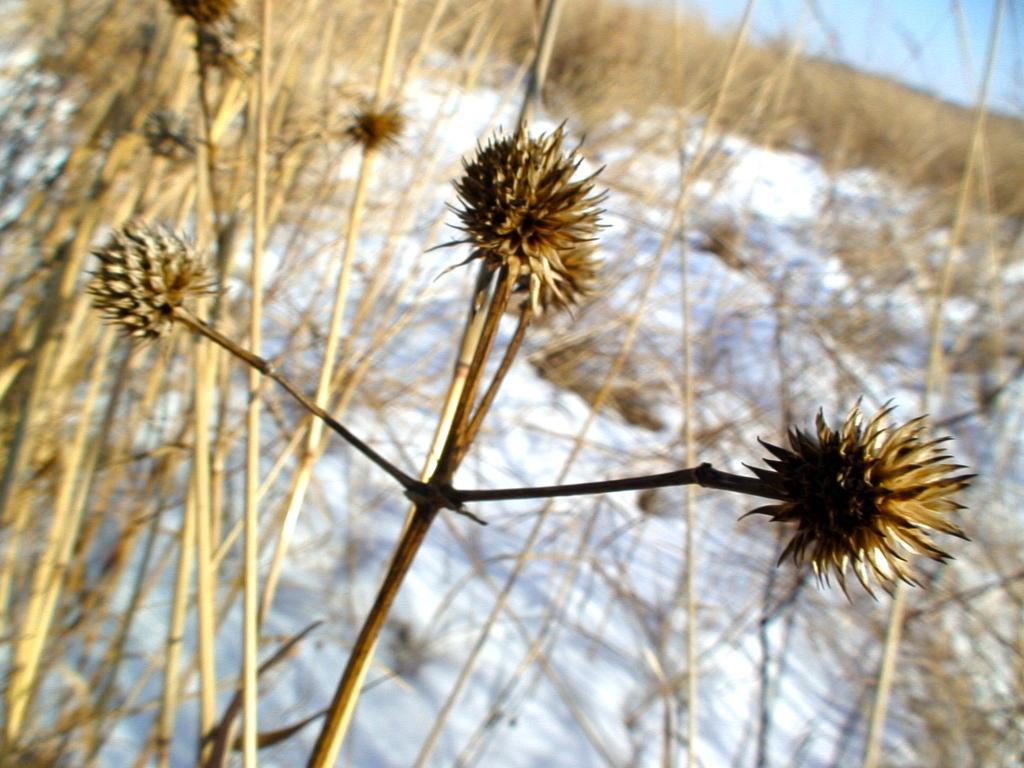What type of vegetation can be seen in the image? There are plants in the image. What is the weather like in the image? There is snow in the image, indicating a cold and likely wintery scene. What part of the natural environment is visible in the image? The sky is visible in the top right hand side corner of the image. What type of curtain can be seen hanging from the plants in the image? There is no curtain present in the image; the plants are not associated with any curtains. 